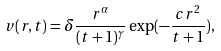<formula> <loc_0><loc_0><loc_500><loc_500>v ( r , t ) = \delta \frac { r ^ { \alpha } } { ( t + 1 ) ^ { \gamma } } \exp ( - \frac { c r ^ { 2 } } { t + 1 } ) ,</formula> 